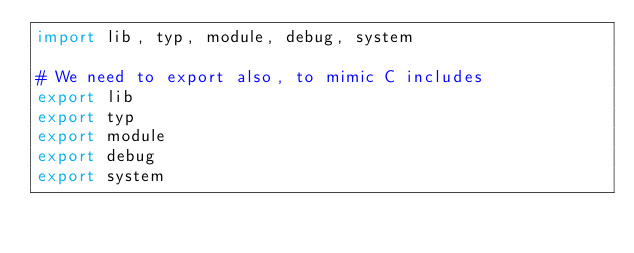Convert code to text. <code><loc_0><loc_0><loc_500><loc_500><_Nim_>import lib, typ, module, debug, system

# We need to export also, to mimic C includes
export lib
export typ
export module
export debug
export system</code> 